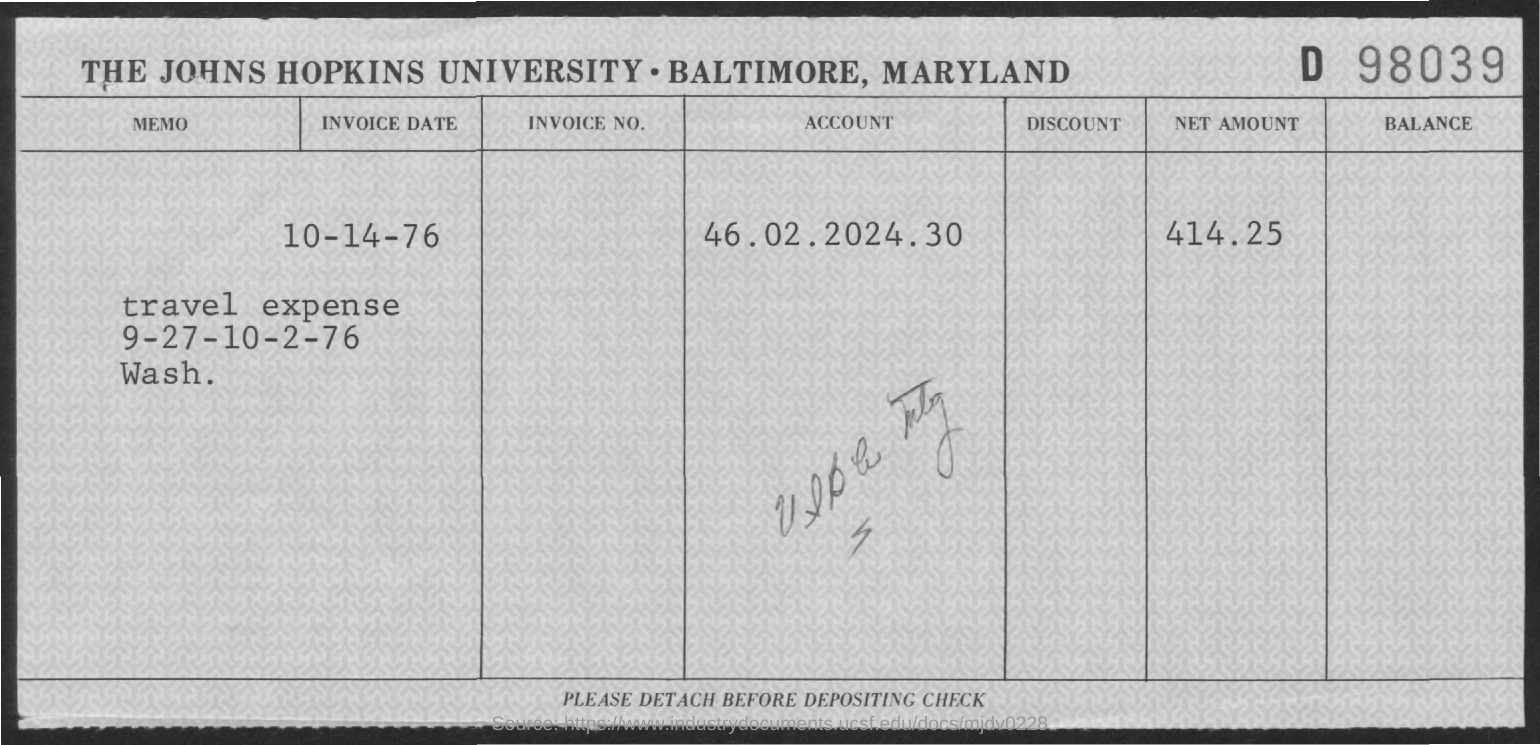What is the invoice date?
Provide a succinct answer. 10-14-76. What is the account number?
Provide a short and direct response. 46.02.2024.30. What is the net amount?
Offer a terse response. 414.25. 